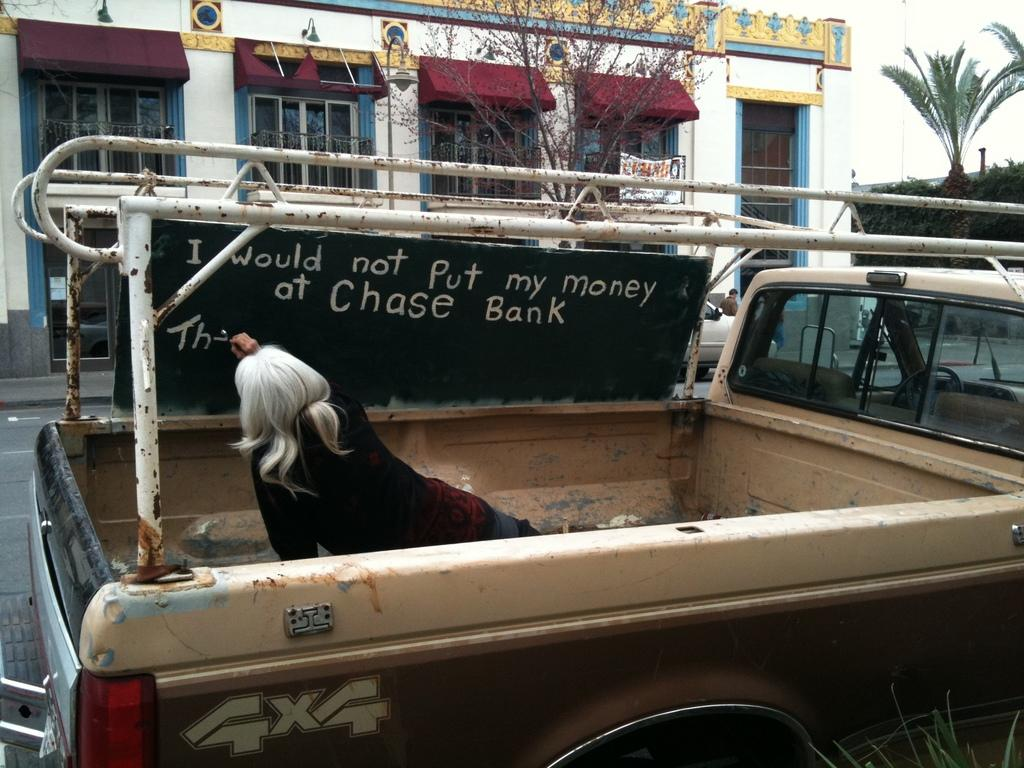Who is present in the image? There is a woman in the image. What object can be seen near the woman? There is a board in the image. What else is visible at the bottom of the image? There is a vehicle in the image. What can be seen in the background of the image? There are trees and a building in the background of the image. What type of bait is being used to catch fish in the image? There is no fishing or bait present in the image. What kind of quartz can be seen in the image? There is no quartz present in the image. 